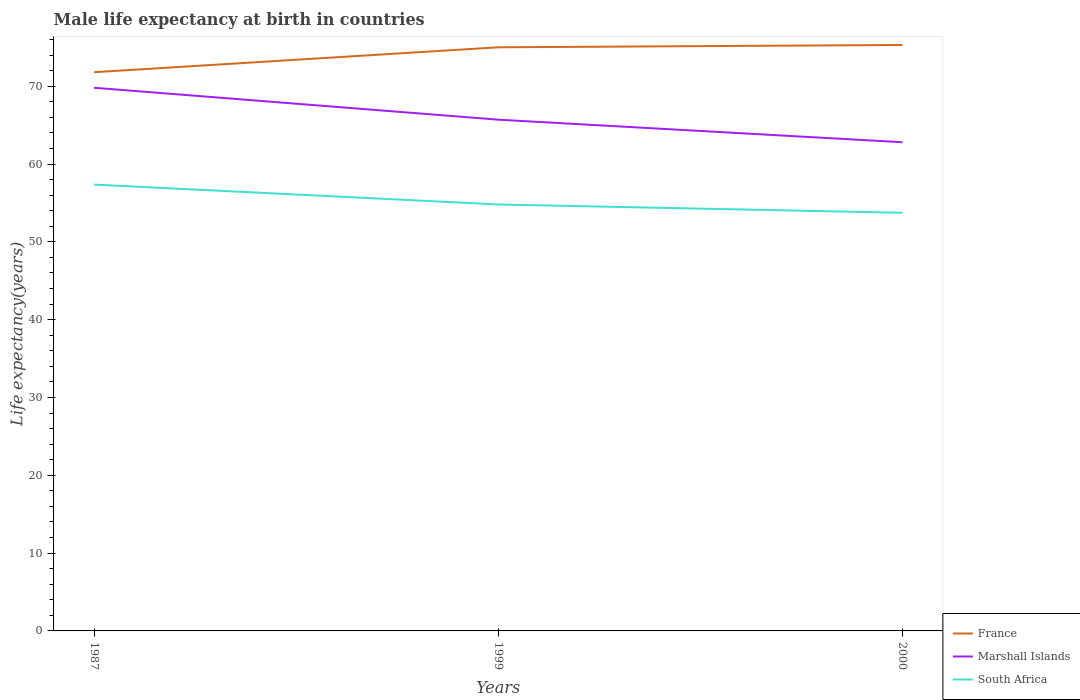How many different coloured lines are there?
Your response must be concise. 3. Across all years, what is the maximum male life expectancy at birth in Marshall Islands?
Your response must be concise. 62.8. In which year was the male life expectancy at birth in Marshall Islands maximum?
Offer a very short reply. 2000. What is the total male life expectancy at birth in France in the graph?
Your answer should be compact. -3.2. What is the difference between the highest and the second highest male life expectancy at birth in South Africa?
Keep it short and to the point. 3.63. Is the male life expectancy at birth in South Africa strictly greater than the male life expectancy at birth in Marshall Islands over the years?
Your answer should be very brief. Yes. How many lines are there?
Your response must be concise. 3. How many years are there in the graph?
Ensure brevity in your answer.  3. What is the difference between two consecutive major ticks on the Y-axis?
Offer a terse response. 10. Are the values on the major ticks of Y-axis written in scientific E-notation?
Offer a very short reply. No. Does the graph contain any zero values?
Your answer should be very brief. No. Does the graph contain grids?
Keep it short and to the point. No. How many legend labels are there?
Keep it short and to the point. 3. What is the title of the graph?
Give a very brief answer. Male life expectancy at birth in countries. Does "Kenya" appear as one of the legend labels in the graph?
Make the answer very short. No. What is the label or title of the Y-axis?
Offer a terse response. Life expectancy(years). What is the Life expectancy(years) of France in 1987?
Provide a succinct answer. 71.8. What is the Life expectancy(years) in Marshall Islands in 1987?
Offer a very short reply. 69.8. What is the Life expectancy(years) of South Africa in 1987?
Offer a very short reply. 57.36. What is the Life expectancy(years) of Marshall Islands in 1999?
Ensure brevity in your answer.  65.7. What is the Life expectancy(years) of South Africa in 1999?
Make the answer very short. 54.8. What is the Life expectancy(years) in France in 2000?
Ensure brevity in your answer.  75.3. What is the Life expectancy(years) in Marshall Islands in 2000?
Provide a short and direct response. 62.8. What is the Life expectancy(years) of South Africa in 2000?
Your answer should be compact. 53.73. Across all years, what is the maximum Life expectancy(years) of France?
Ensure brevity in your answer.  75.3. Across all years, what is the maximum Life expectancy(years) in Marshall Islands?
Your answer should be compact. 69.8. Across all years, what is the maximum Life expectancy(years) of South Africa?
Offer a very short reply. 57.36. Across all years, what is the minimum Life expectancy(years) of France?
Your response must be concise. 71.8. Across all years, what is the minimum Life expectancy(years) of Marshall Islands?
Offer a terse response. 62.8. Across all years, what is the minimum Life expectancy(years) of South Africa?
Make the answer very short. 53.73. What is the total Life expectancy(years) of France in the graph?
Keep it short and to the point. 222.1. What is the total Life expectancy(years) in Marshall Islands in the graph?
Make the answer very short. 198.3. What is the total Life expectancy(years) of South Africa in the graph?
Offer a terse response. 165.9. What is the difference between the Life expectancy(years) of South Africa in 1987 and that in 1999?
Offer a terse response. 2.56. What is the difference between the Life expectancy(years) of Marshall Islands in 1987 and that in 2000?
Your response must be concise. 7. What is the difference between the Life expectancy(years) of South Africa in 1987 and that in 2000?
Your response must be concise. 3.63. What is the difference between the Life expectancy(years) in France in 1999 and that in 2000?
Offer a very short reply. -0.3. What is the difference between the Life expectancy(years) of Marshall Islands in 1999 and that in 2000?
Ensure brevity in your answer.  2.9. What is the difference between the Life expectancy(years) in South Africa in 1999 and that in 2000?
Keep it short and to the point. 1.07. What is the difference between the Life expectancy(years) in France in 1987 and the Life expectancy(years) in Marshall Islands in 1999?
Offer a very short reply. 6.1. What is the difference between the Life expectancy(years) in France in 1987 and the Life expectancy(years) in South Africa in 1999?
Offer a very short reply. 17. What is the difference between the Life expectancy(years) of Marshall Islands in 1987 and the Life expectancy(years) of South Africa in 1999?
Provide a short and direct response. 15. What is the difference between the Life expectancy(years) in France in 1987 and the Life expectancy(years) in South Africa in 2000?
Your answer should be very brief. 18.07. What is the difference between the Life expectancy(years) of Marshall Islands in 1987 and the Life expectancy(years) of South Africa in 2000?
Offer a very short reply. 16.07. What is the difference between the Life expectancy(years) of France in 1999 and the Life expectancy(years) of South Africa in 2000?
Your answer should be very brief. 21.27. What is the difference between the Life expectancy(years) in Marshall Islands in 1999 and the Life expectancy(years) in South Africa in 2000?
Your response must be concise. 11.97. What is the average Life expectancy(years) of France per year?
Your answer should be compact. 74.03. What is the average Life expectancy(years) of Marshall Islands per year?
Provide a short and direct response. 66.1. What is the average Life expectancy(years) of South Africa per year?
Offer a very short reply. 55.3. In the year 1987, what is the difference between the Life expectancy(years) in France and Life expectancy(years) in Marshall Islands?
Your response must be concise. 2. In the year 1987, what is the difference between the Life expectancy(years) of France and Life expectancy(years) of South Africa?
Provide a short and direct response. 14.44. In the year 1987, what is the difference between the Life expectancy(years) of Marshall Islands and Life expectancy(years) of South Africa?
Provide a short and direct response. 12.44. In the year 1999, what is the difference between the Life expectancy(years) in France and Life expectancy(years) in South Africa?
Ensure brevity in your answer.  20.2. In the year 1999, what is the difference between the Life expectancy(years) in Marshall Islands and Life expectancy(years) in South Africa?
Your answer should be very brief. 10.9. In the year 2000, what is the difference between the Life expectancy(years) in France and Life expectancy(years) in South Africa?
Your answer should be very brief. 21.57. In the year 2000, what is the difference between the Life expectancy(years) in Marshall Islands and Life expectancy(years) in South Africa?
Provide a short and direct response. 9.07. What is the ratio of the Life expectancy(years) of France in 1987 to that in 1999?
Your answer should be compact. 0.96. What is the ratio of the Life expectancy(years) of Marshall Islands in 1987 to that in 1999?
Offer a terse response. 1.06. What is the ratio of the Life expectancy(years) of South Africa in 1987 to that in 1999?
Make the answer very short. 1.05. What is the ratio of the Life expectancy(years) in France in 1987 to that in 2000?
Your response must be concise. 0.95. What is the ratio of the Life expectancy(years) of Marshall Islands in 1987 to that in 2000?
Your answer should be compact. 1.11. What is the ratio of the Life expectancy(years) of South Africa in 1987 to that in 2000?
Make the answer very short. 1.07. What is the ratio of the Life expectancy(years) of Marshall Islands in 1999 to that in 2000?
Make the answer very short. 1.05. What is the difference between the highest and the second highest Life expectancy(years) of France?
Provide a short and direct response. 0.3. What is the difference between the highest and the second highest Life expectancy(years) in Marshall Islands?
Give a very brief answer. 4.1. What is the difference between the highest and the second highest Life expectancy(years) in South Africa?
Provide a short and direct response. 2.56. What is the difference between the highest and the lowest Life expectancy(years) of France?
Your answer should be very brief. 3.5. What is the difference between the highest and the lowest Life expectancy(years) of Marshall Islands?
Your answer should be very brief. 7. What is the difference between the highest and the lowest Life expectancy(years) in South Africa?
Provide a succinct answer. 3.63. 